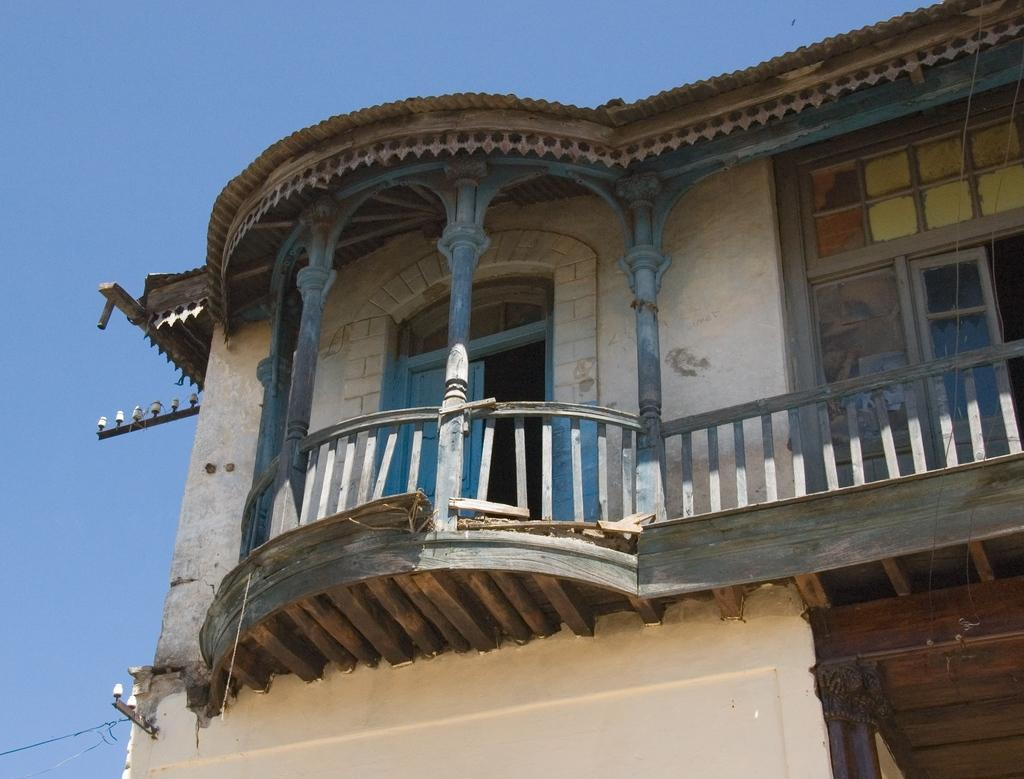What type of structure is in the foreground of the image? There is a building in the foreground of the image. What material is used for the railing on the building? The building has wooden railing. What features can be seen on the building's exterior? The building has windows and a door. What can be seen at the top of the image? The sky is visible at the top of the image. What type of furniture can be seen in the image? There is no furniture visible in the image; it primarily features a building with a wooden railing, windows, and a door. 